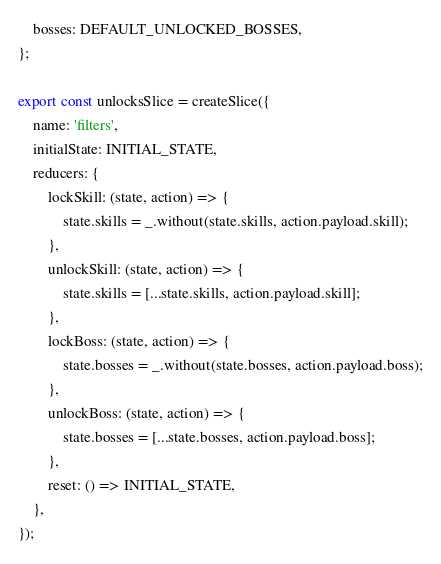Convert code to text. <code><loc_0><loc_0><loc_500><loc_500><_JavaScript_>    bosses: DEFAULT_UNLOCKED_BOSSES,
};

export const unlocksSlice = createSlice({
    name: 'filters',
    initialState: INITIAL_STATE,
    reducers: {
        lockSkill: (state, action) => {
            state.skills = _.without(state.skills, action.payload.skill);
        },
        unlockSkill: (state, action) => {
            state.skills = [...state.skills, action.payload.skill];
        },
        lockBoss: (state, action) => {
            state.bosses = _.without(state.bosses, action.payload.boss);
        },
        unlockBoss: (state, action) => {
            state.bosses = [...state.bosses, action.payload.boss];
        },
        reset: () => INITIAL_STATE,
    },
});
</code> 